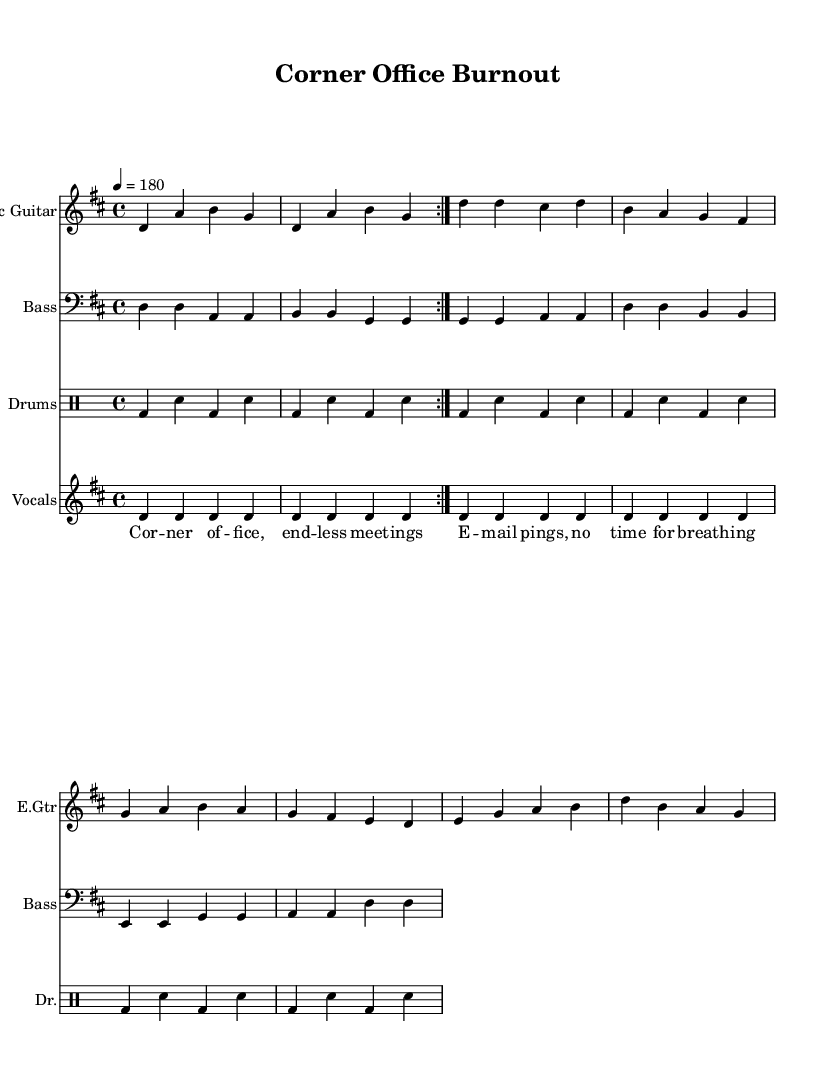What is the key signature of this music? The key signature is indicated before the first measure of the music, showing two sharps, which corresponds to D major.
Answer: D major What is the time signature of this music? The time signature is indicated at the beginning of the score, showing four beats per measure, thus it is 4/4.
Answer: 4/4 What is the tempo marking for this piece? The tempo marking, located above the staff, indicates a speed of quarter note equals 180 beats per minute.
Answer: 180 How many measures are in the electric guitar part? By counting the number of measure signs within the electric guitar section, we can see there are eight measures repeated.
Answer: Eight measures What do the lyrics primarily address? The lyrics express themes related to work-life balance and the pressures of leadership roles, particularly focusing on burnout.
Answer: Work-life balance and burnout How does the structure of the song contribute to its punk genre? The song features a simple, repetitive chord progression and aggressive rhythm, which are characteristic of the punk genre, reflecting urgency and rebellion against burnout.
Answer: Simple and aggressive What is the type of rhythm indicated for the drum part? The drum part primarily uses a steady bass drum and snare pattern, creating a driving rhythm typical of punk music.
Answer: Steady bass and snare pattern 